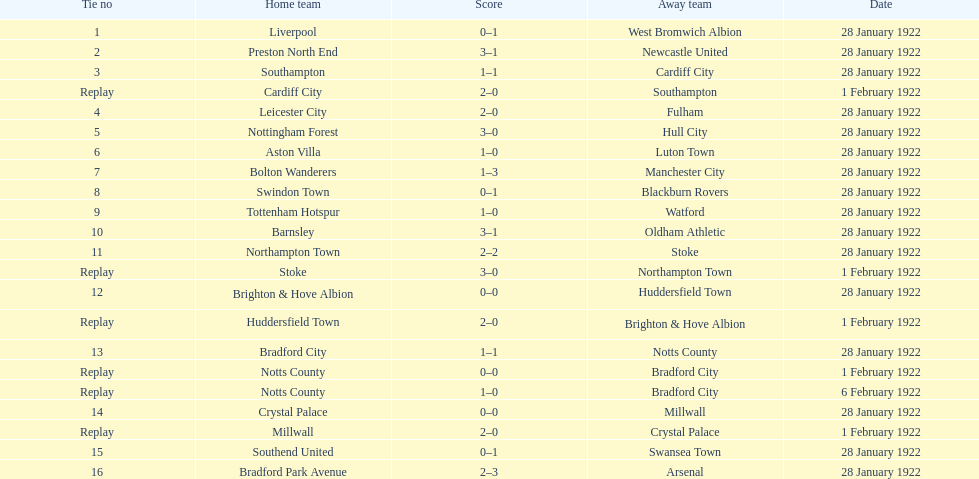What is the sum of points scored in the second round proper? 45. 